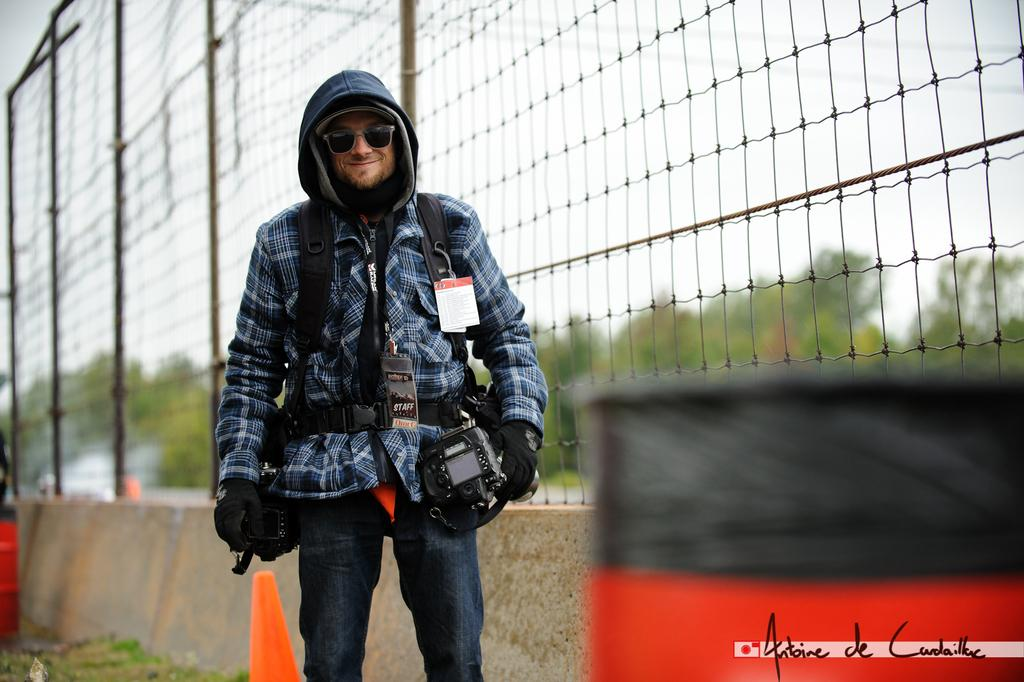What is the main subject of the image? There is a person standing in the image. What can be seen in the background of the image? There is sky, trees, and a fence visible in the background of the image. What type of head is the secretary wearing in the image? There is no secretary or headwear present in the image; it features a person standing in front of a background with sky, trees, and a fence. 